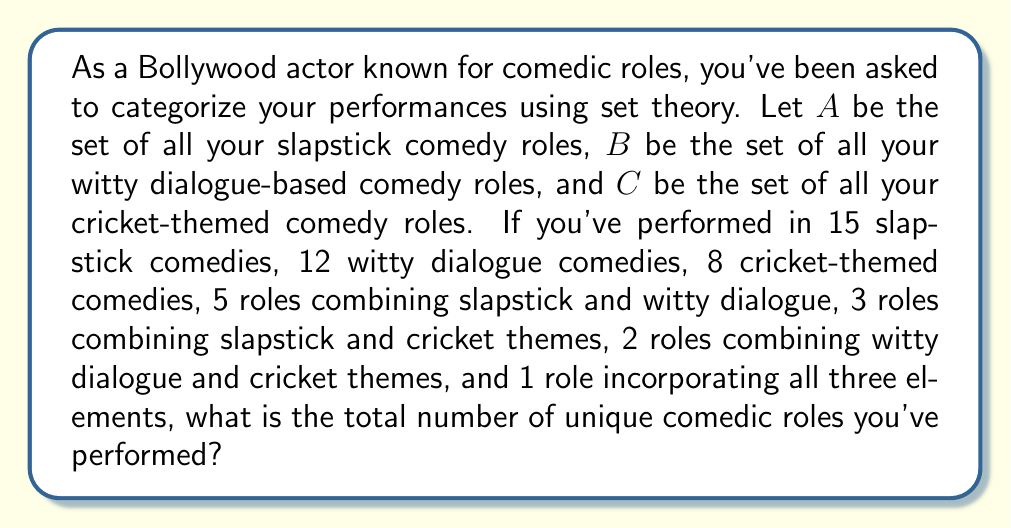Could you help me with this problem? To solve this problem, we'll use the principle of inclusion-exclusion from set theory. Let's break it down step-by-step:

1) First, let's define our sets:
   $A$ = set of slapstick comedy roles
   $B$ = set of witty dialogue-based comedy roles
   $C$ = set of cricket-themed comedy roles

2) We're given the following information:
   $|A| = 15$, $|B| = 12$, $|C| = 8$
   $|A \cap B| = 5$, $|A \cap C| = 3$, $|B \cap C| = 2$
   $|A \cap B \cap C| = 1$

3) The principle of inclusion-exclusion for three sets is:

   $$|A \cup B \cup C| = |A| + |B| + |C| - |A \cap B| - |A \cap C| - |B \cap C| + |A \cap B \cap C|$$

4) Let's substitute our values:

   $$|A \cup B \cup C| = 15 + 12 + 8 - 5 - 3 - 2 + 1$$

5) Now we can calculate:

   $$|A \cup B \cup C| = 35 - 10 + 1 = 26$$

Therefore, the total number of unique comedic roles you've performed is 26.
Answer: 26 unique comedic roles 